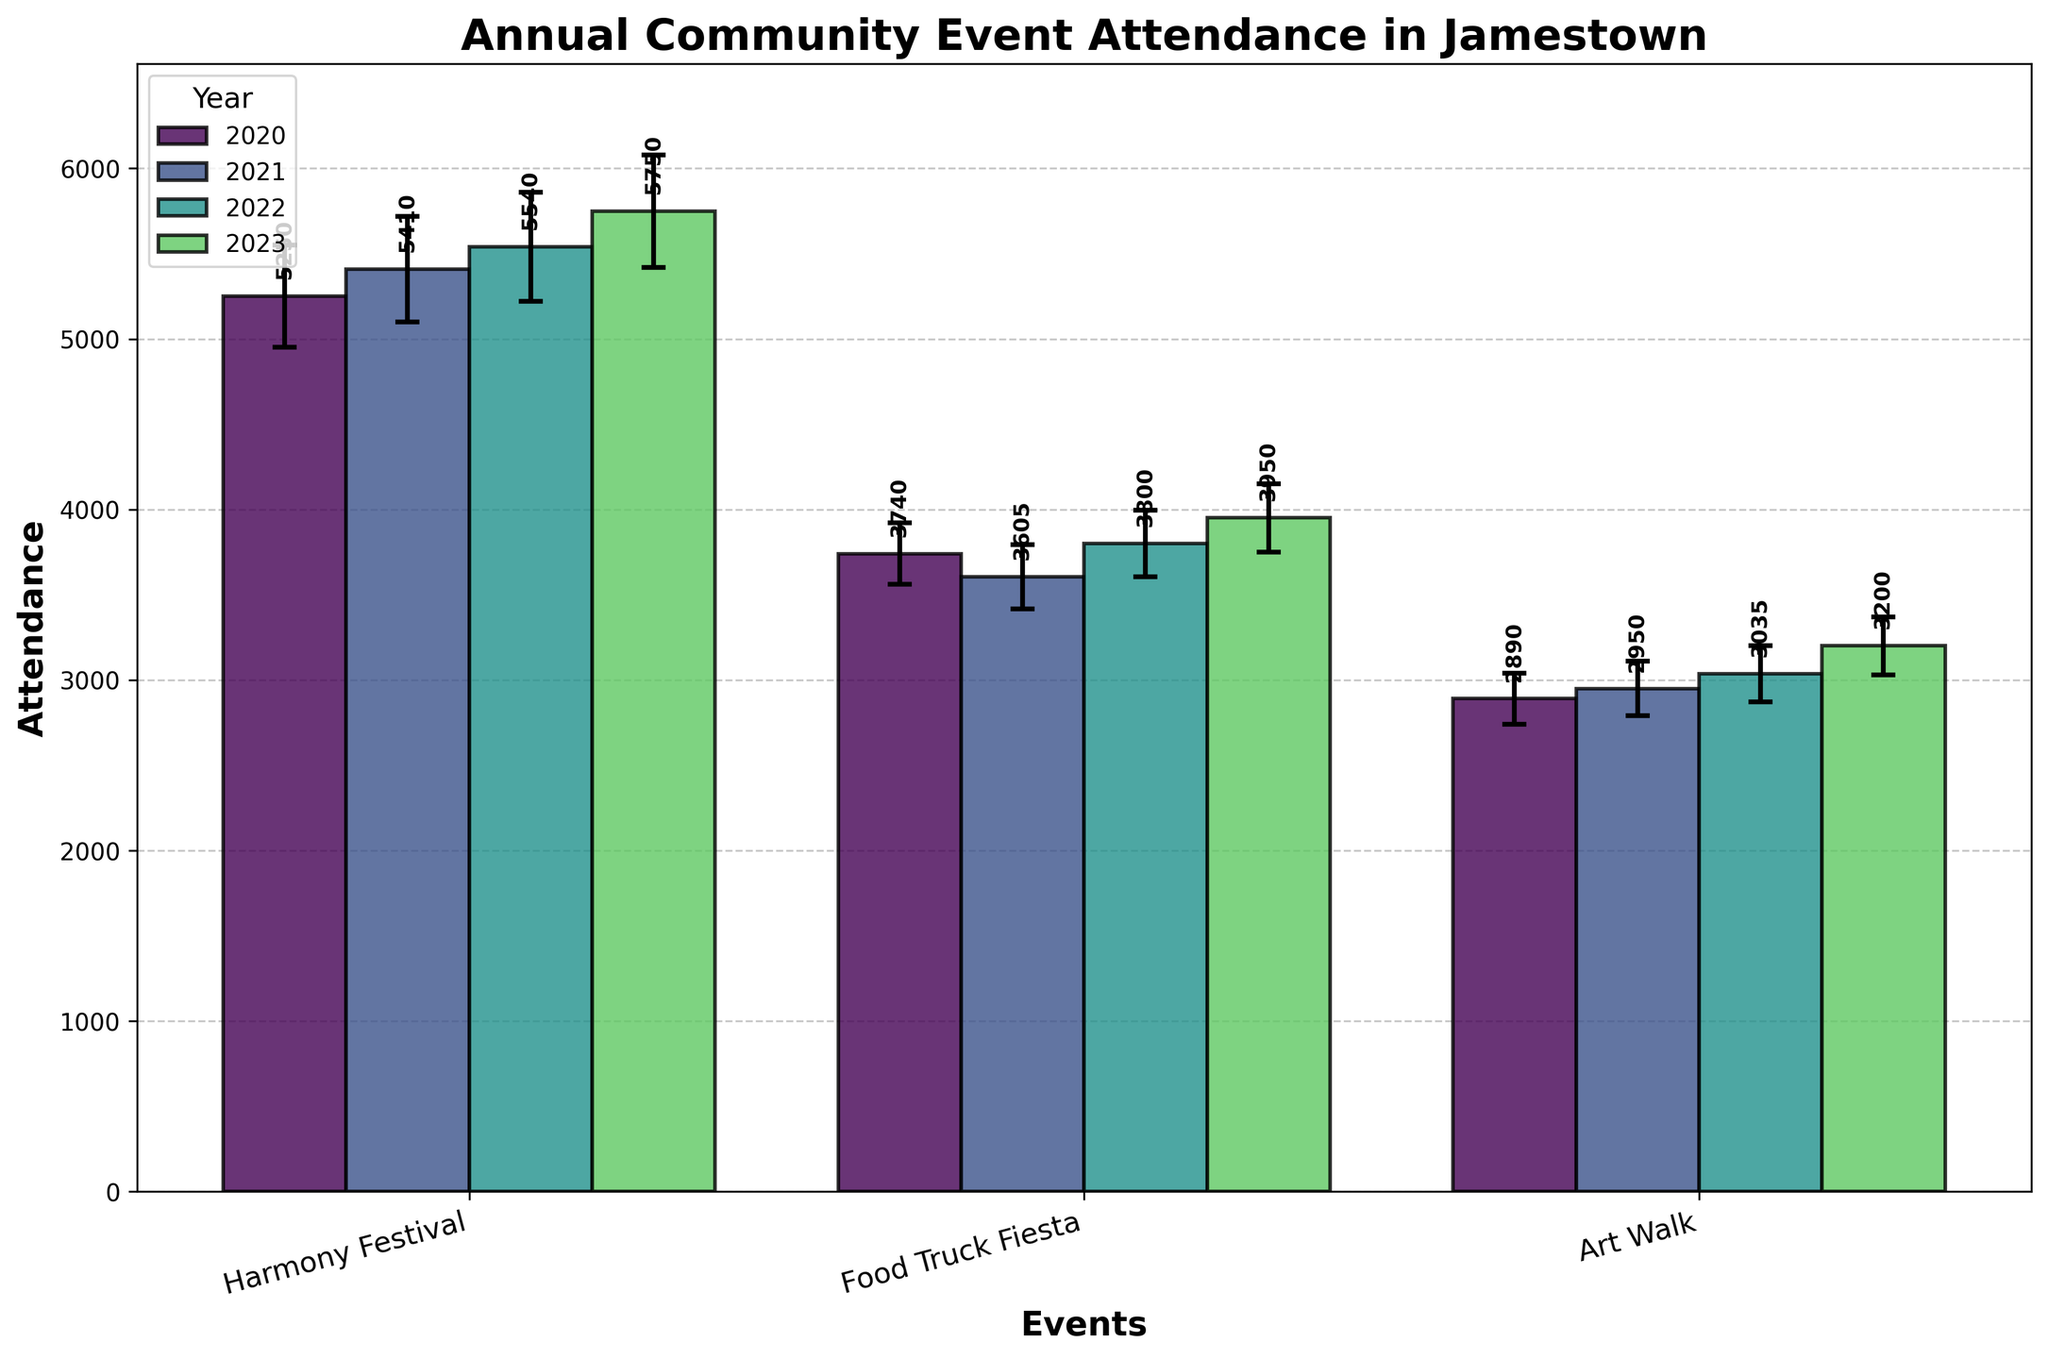What is the title of the figure? The title is directly written at the top of the figure.
Answer: Annual Community Event Attendance in Jamestown Which event had the highest attendance in 2023? Look at the bar heights for the year 2023. The tallest bar in 2023 corresponds to the Harmony Festival.
Answer: Harmony Festival What is the attendance of the Food Truck Fiesta in 2020? Identify the bar associated with Food Truck Fiesta for the year 2020 and read the value attached to it.
Answer: 3740 Which event shows a consistent increase in attendance every year? Trace the height of the bars for each event across the years 2020 to 2023. The Harmony Festival shows a consistent increase each year.
Answer: Harmony Festival What was the year-over-year change percentage for the Art Walk in 2023? Look at the figure's error bars and locate the data labels. The Art Walk in 2023 shows a year-over-year change of 5.43%.
Answer: 5.43% How much did the attendance for the Harmony Festival increase from 2020 to 2023? Find the attendance for the Harmony Festival in 2020 and 2023 and calculate the difference: 5750 - 5250.
Answer: 500 What is the margin of error for the Food Truck Fiesta in 2022? Locate the error bar for the Food Truck Fiesta in 2022 and check its value.
Answer: 195 Compare the attendance changes for the Food Truck Fiesta and Art Walk from 2021 to 2022. Look at the height differences for both events between 2021 and 2022. The Food Truck Fiesta increased by 195, while the Art Walk increased by 85.
Answer: Food Truck Fiesta: 195, Art Walk: 85 Which event had the smallest margin of error in 2021? Observe the error bars for 2021 and find the smallest one, which corresponds to the Art Walk.
Answer: Art Walk What is the average attendance of the Art Walk from 2020 to 2023? Add the attendance numbers for the Art Walk in each year (2890 + 2950 + 3035 + 3200) and divide by the number of years (4). The average attendance is (2890 + 2950 + 3035 + 3200)/4 = 3018.75.
Answer: 3018.75 